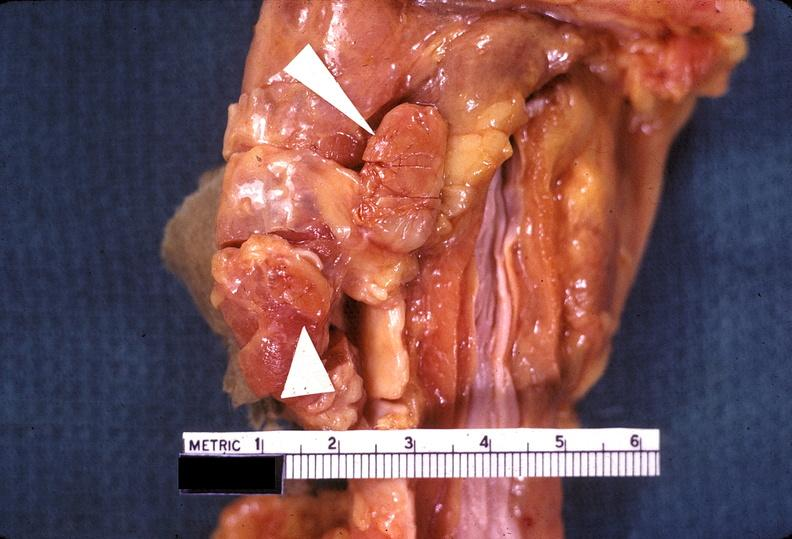s subdiaphragmatic abscess present?
Answer the question using a single word or phrase. No 